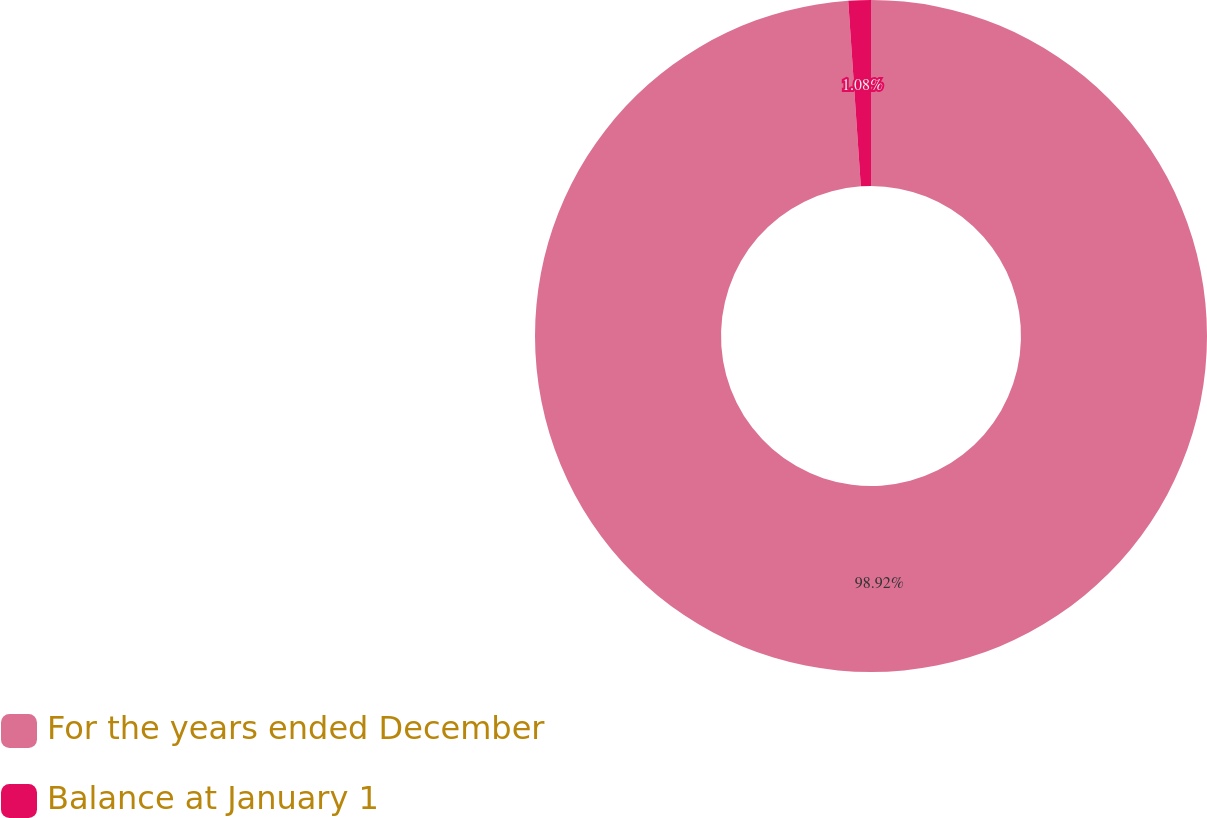<chart> <loc_0><loc_0><loc_500><loc_500><pie_chart><fcel>For the years ended December<fcel>Balance at January 1<nl><fcel>98.92%<fcel>1.08%<nl></chart> 